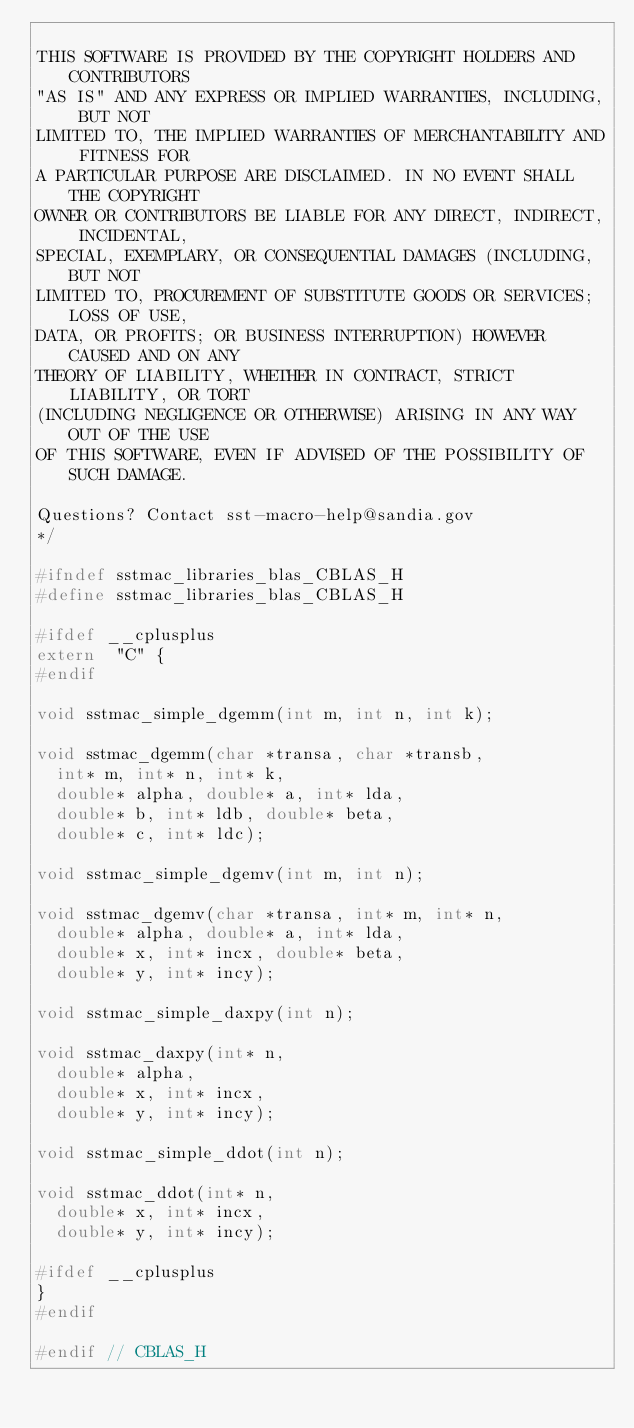Convert code to text. <code><loc_0><loc_0><loc_500><loc_500><_C_>
THIS SOFTWARE IS PROVIDED BY THE COPYRIGHT HOLDERS AND CONTRIBUTORS
"AS IS" AND ANY EXPRESS OR IMPLIED WARRANTIES, INCLUDING, BUT NOT
LIMITED TO, THE IMPLIED WARRANTIES OF MERCHANTABILITY AND FITNESS FOR
A PARTICULAR PURPOSE ARE DISCLAIMED. IN NO EVENT SHALL THE COPYRIGHT
OWNER OR CONTRIBUTORS BE LIABLE FOR ANY DIRECT, INDIRECT, INCIDENTAL,
SPECIAL, EXEMPLARY, OR CONSEQUENTIAL DAMAGES (INCLUDING, BUT NOT
LIMITED TO, PROCUREMENT OF SUBSTITUTE GOODS OR SERVICES; LOSS OF USE,
DATA, OR PROFITS; OR BUSINESS INTERRUPTION) HOWEVER CAUSED AND ON ANY
THEORY OF LIABILITY, WHETHER IN CONTRACT, STRICT LIABILITY, OR TORT
(INCLUDING NEGLIGENCE OR OTHERWISE) ARISING IN ANY WAY OUT OF THE USE
OF THIS SOFTWARE, EVEN IF ADVISED OF THE POSSIBILITY OF SUCH DAMAGE.

Questions? Contact sst-macro-help@sandia.gov
*/

#ifndef sstmac_libraries_blas_CBLAS_H
#define sstmac_libraries_blas_CBLAS_H

#ifdef __cplusplus
extern  "C" {
#endif

void sstmac_simple_dgemm(int m, int n, int k);

void sstmac_dgemm(char *transa, char *transb,
  int* m, int* n, int* k,
  double* alpha, double* a, int* lda,
  double* b, int* ldb, double* beta,
  double* c, int* ldc);

void sstmac_simple_dgemv(int m, int n);

void sstmac_dgemv(char *transa, int* m, int* n,
  double* alpha, double* a, int* lda,
  double* x, int* incx, double* beta,
  double* y, int* incy);

void sstmac_simple_daxpy(int n);

void sstmac_daxpy(int* n,
  double* alpha,
  double* x, int* incx,
  double* y, int* incy);

void sstmac_simple_ddot(int n);

void sstmac_ddot(int* n,
  double* x, int* incx,
  double* y, int* incy);

#ifdef __cplusplus
}
#endif

#endif // CBLAS_H
</code> 